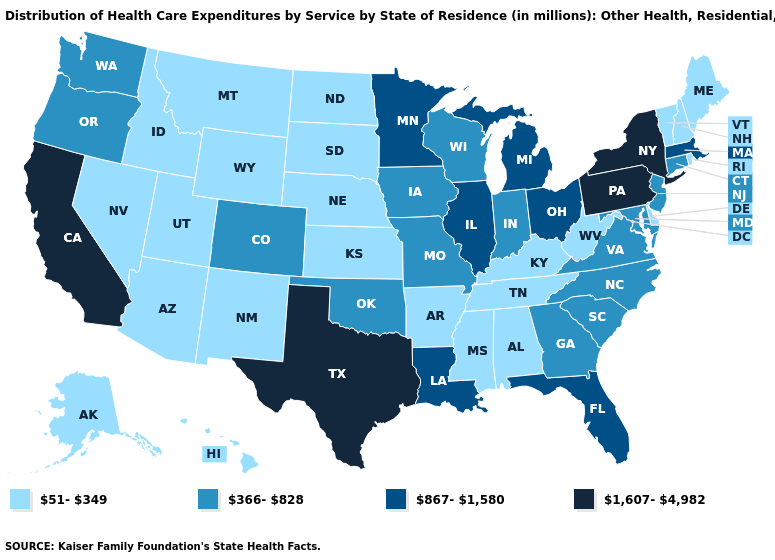Among the states that border Pennsylvania , which have the lowest value?
Keep it brief. Delaware, West Virginia. Does Pennsylvania have the lowest value in the USA?
Write a very short answer. No. Does Montana have the same value as Rhode Island?
Keep it brief. Yes. Name the states that have a value in the range 51-349?
Write a very short answer. Alabama, Alaska, Arizona, Arkansas, Delaware, Hawaii, Idaho, Kansas, Kentucky, Maine, Mississippi, Montana, Nebraska, Nevada, New Hampshire, New Mexico, North Dakota, Rhode Island, South Dakota, Tennessee, Utah, Vermont, West Virginia, Wyoming. Name the states that have a value in the range 867-1,580?
Keep it brief. Florida, Illinois, Louisiana, Massachusetts, Michigan, Minnesota, Ohio. Name the states that have a value in the range 867-1,580?
Be succinct. Florida, Illinois, Louisiana, Massachusetts, Michigan, Minnesota, Ohio. Among the states that border Iowa , which have the highest value?
Keep it brief. Illinois, Minnesota. Which states have the highest value in the USA?
Concise answer only. California, New York, Pennsylvania, Texas. Does Minnesota have a higher value than Massachusetts?
Write a very short answer. No. Does Hawaii have the highest value in the USA?
Write a very short answer. No. Among the states that border New York , does Massachusetts have the highest value?
Short answer required. No. Name the states that have a value in the range 366-828?
Give a very brief answer. Colorado, Connecticut, Georgia, Indiana, Iowa, Maryland, Missouri, New Jersey, North Carolina, Oklahoma, Oregon, South Carolina, Virginia, Washington, Wisconsin. Among the states that border Vermont , which have the lowest value?
Answer briefly. New Hampshire. What is the value of Connecticut?
Write a very short answer. 366-828. What is the value of Wyoming?
Keep it brief. 51-349. 